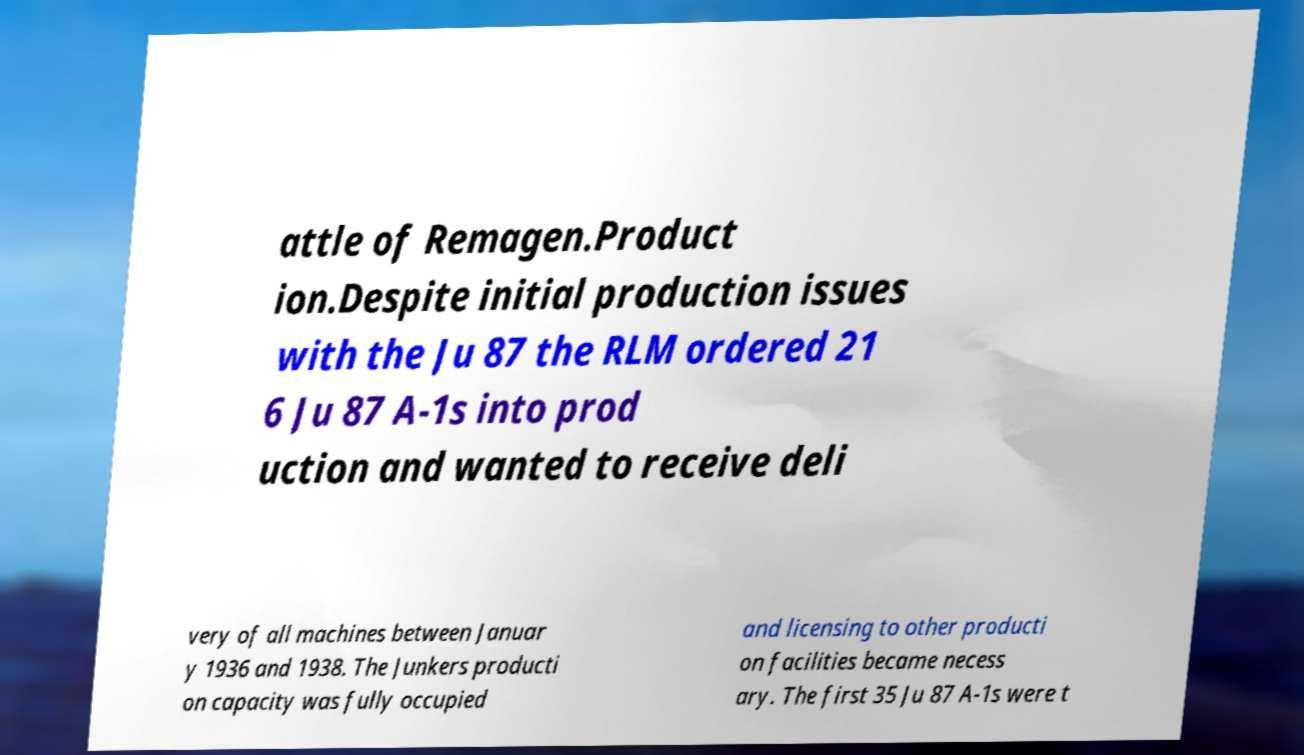I need the written content from this picture converted into text. Can you do that? attle of Remagen.Product ion.Despite initial production issues with the Ju 87 the RLM ordered 21 6 Ju 87 A-1s into prod uction and wanted to receive deli very of all machines between Januar y 1936 and 1938. The Junkers producti on capacity was fully occupied and licensing to other producti on facilities became necess ary. The first 35 Ju 87 A-1s were t 